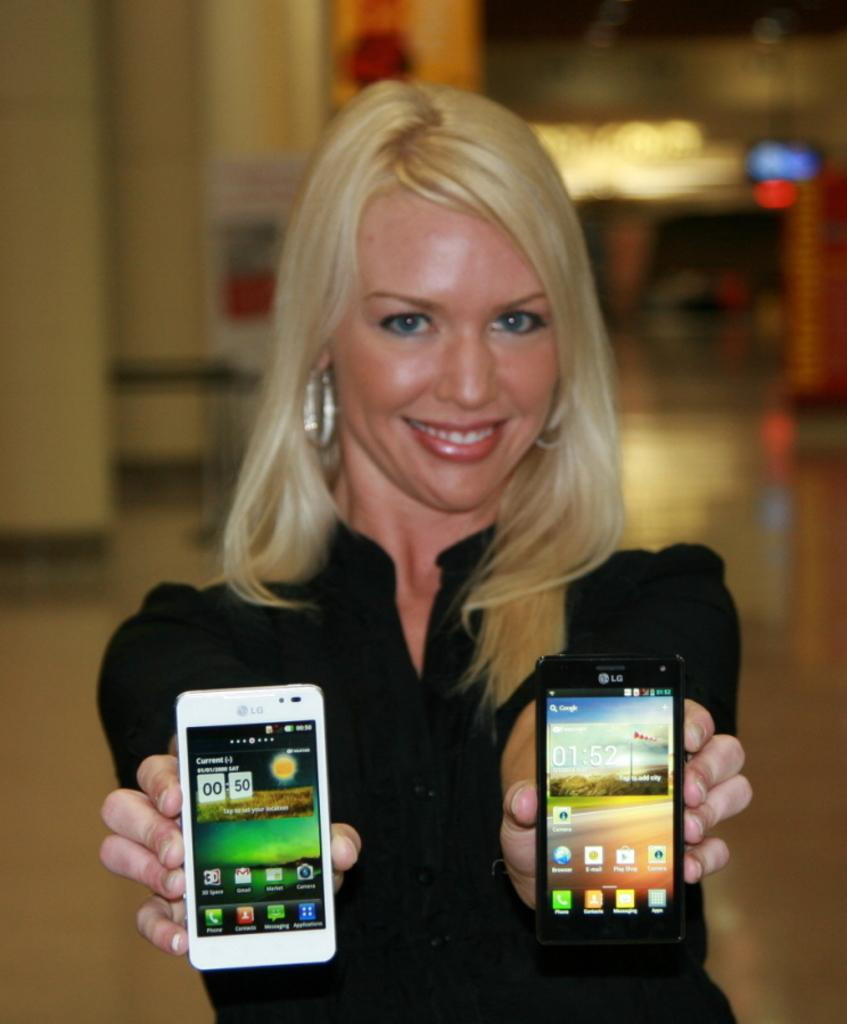Who is the main subject in the image? There is a woman in the image. What is the woman holding in her hands? The woman is holding two mobiles, one in each hand. What can be seen in the background of the image? There is a wall visible in the background of the image. How many teeth can be seen in the woman's smile in the image? There is no indication of the woman's teeth or smile in the image, so it cannot be determined. 